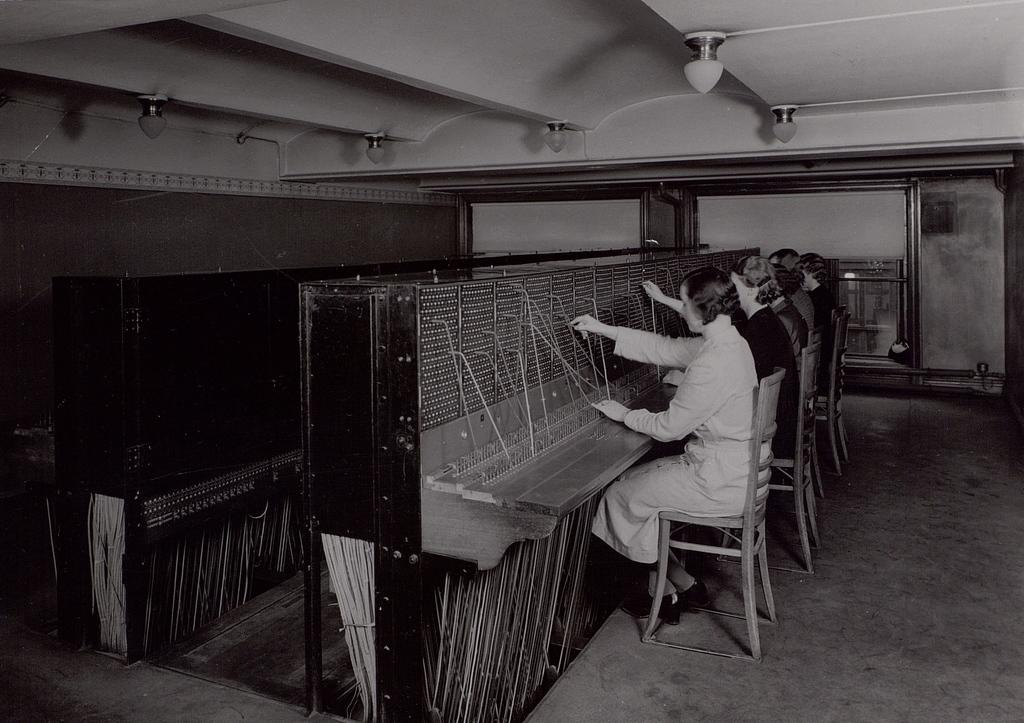What are the people in the image doing? The people in the image are sitting on chairs and working on a machine. What can be seen on the roof in the image? There are lights on the roof in the image. What is visible on the glass door in the image? There are reflections on the glass door in the image. What type of oatmeal is being prepared in the image? There is no oatmeal present in the image; the people are working on a machine. How does the statement "I love this machine" relate to the image? The statement "I love this machine" is not present in the image; it is an external comment that cannot be confirmed or denied based on the image alone. 